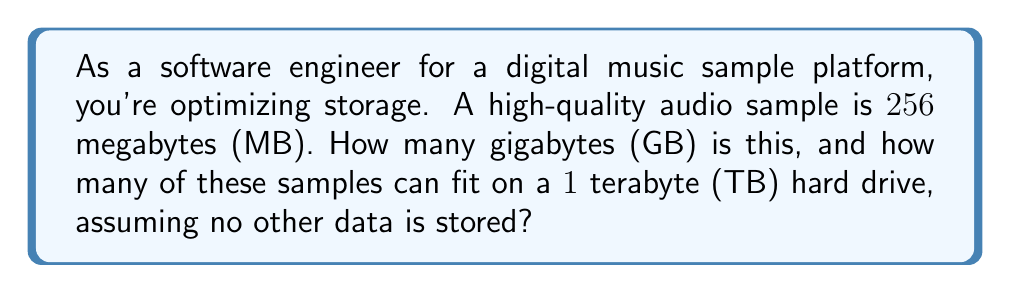Can you answer this question? Let's approach this step-by-step:

1) First, let's convert 256 MB to GB:
   $$ 256 \text{ MB} = \frac{256}{1024} \text{ GB} = 0.25 \text{ GB} $$
   This is because 1 GB = 1024 MB.

2) Now, let's determine how many of these samples can fit in 1 TB:
   First, we need to convert 1 TB to GB:
   $$ 1 \text{ TB} = 1024 \text{ GB} $$

3) To find how many samples fit, we divide the total storage by the size of one sample:
   $$ \text{Number of samples} = \frac{1024 \text{ GB}}{0.25 \text{ GB/sample}} = 4096 \text{ samples} $$

Therefore, the 256 MB sample is equivalent to 0.25 GB, and 4096 of these samples can fit on a 1 TB hard drive.
Answer: 0.25 GB; 4096 samples 